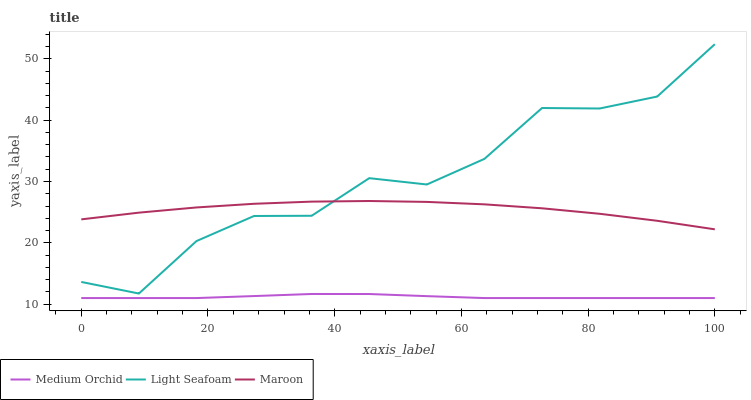Does Maroon have the minimum area under the curve?
Answer yes or no. No. Does Maroon have the maximum area under the curve?
Answer yes or no. No. Is Maroon the smoothest?
Answer yes or no. No. Is Maroon the roughest?
Answer yes or no. No. Does Light Seafoam have the lowest value?
Answer yes or no. No. Does Maroon have the highest value?
Answer yes or no. No. Is Medium Orchid less than Maroon?
Answer yes or no. Yes. Is Light Seafoam greater than Medium Orchid?
Answer yes or no. Yes. Does Medium Orchid intersect Maroon?
Answer yes or no. No. 